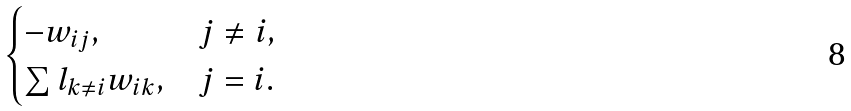<formula> <loc_0><loc_0><loc_500><loc_500>\begin{cases} - w _ { i j } , & j \ne i , \\ \sum l _ { k \ne i } w _ { i k } , & j = i . \end{cases}</formula> 